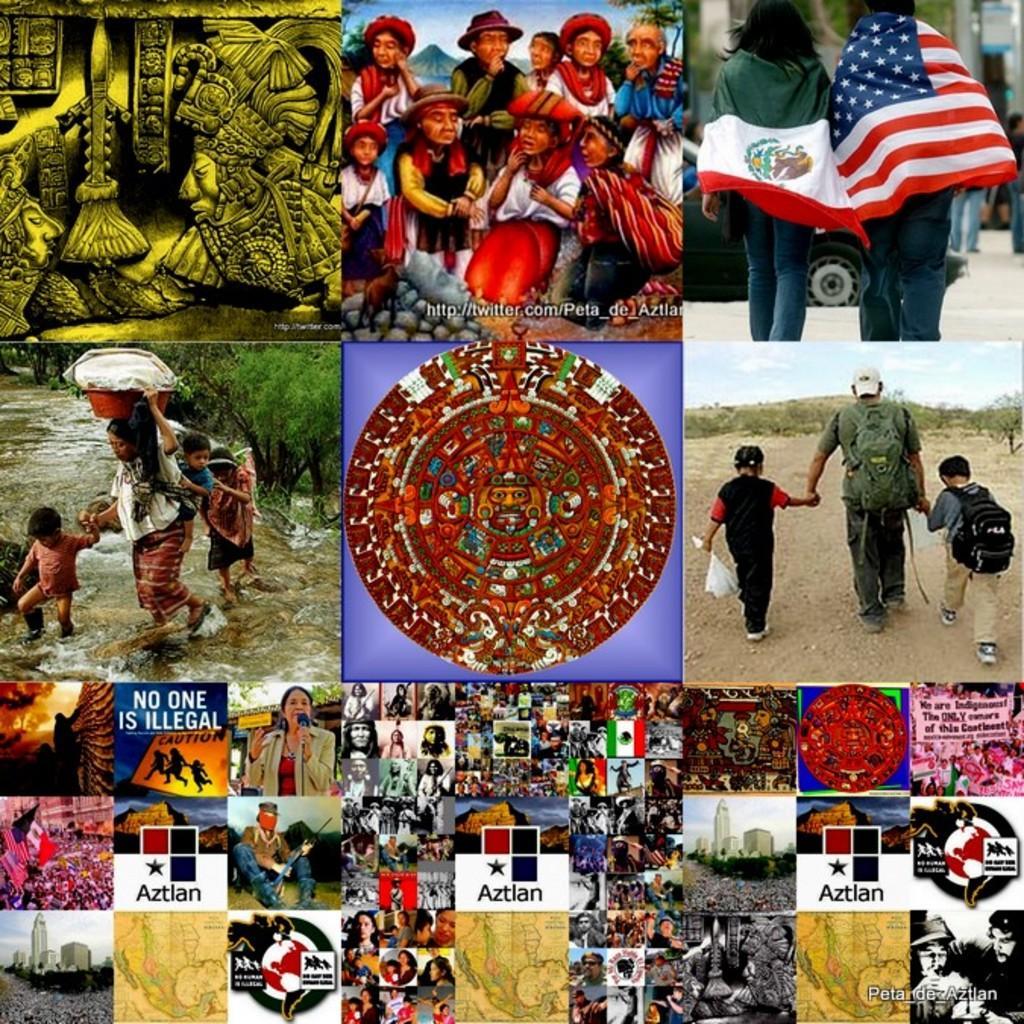Please provide a concise description of this image. This is a collage picture. I can see group of people, flags, buildings, maps, sculptures, there is water, there are trees and there are watermarks on the image. 